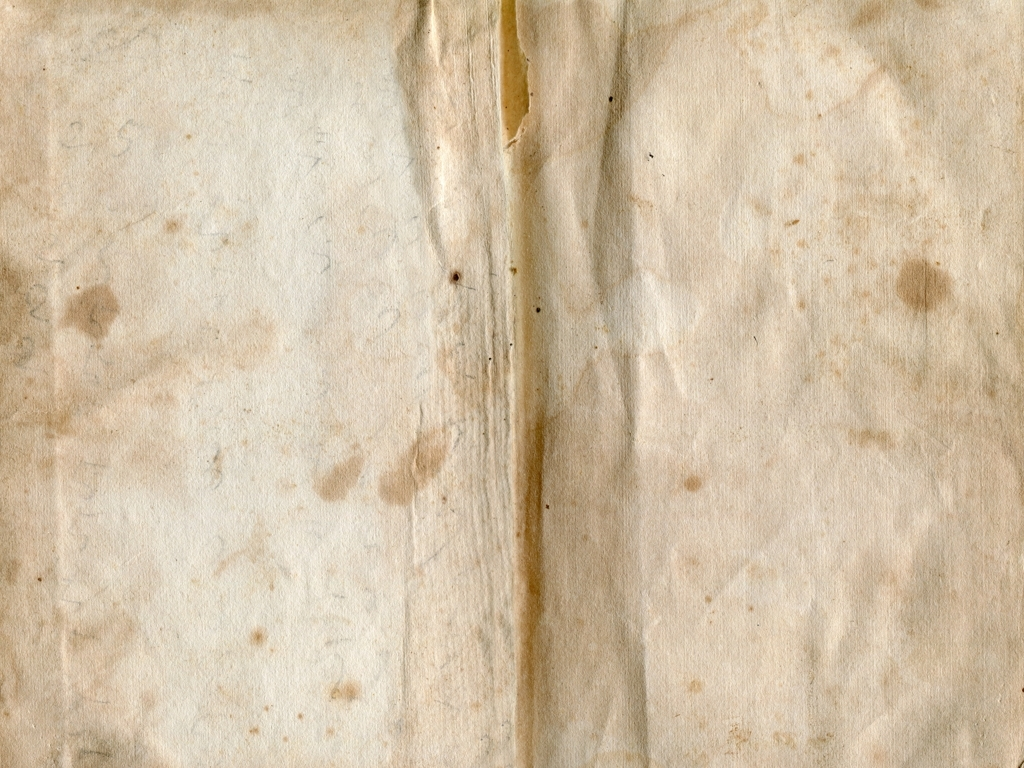What can the stains and marks tell us about the paper's past? The stains and marks on the paper could indicate frequent handling, exposure to various elements, or the presence of iron-gall ink, which can corrode paper over time. These signs of wear may reflect its journey through different environments and its usage over the years. 